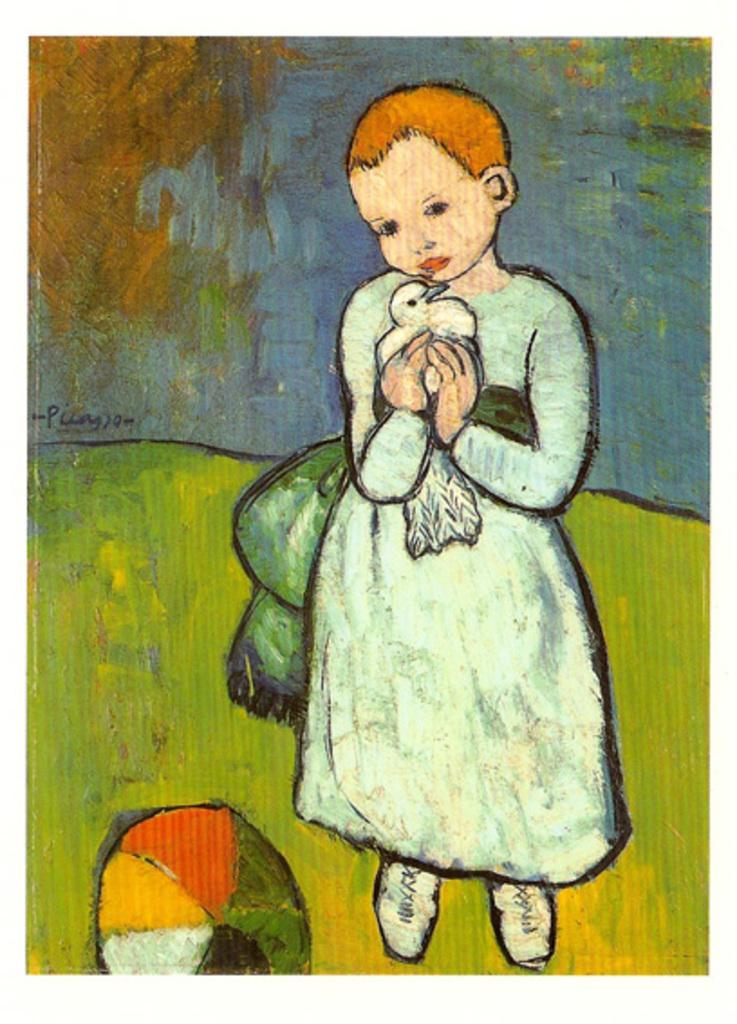What is the main subject of the image? There is a painting in the image. What is happening in the painting? A person is holding a bird in the painting. What other objects can be seen in the painting? There is a ball in the painting. How would you describe the background of the painting? The background of the painting is colorful. What type of metal is used to create the street in the image? There is no street present in the image; it features a painting with a person holding a bird, a ball, and a colorful background. 